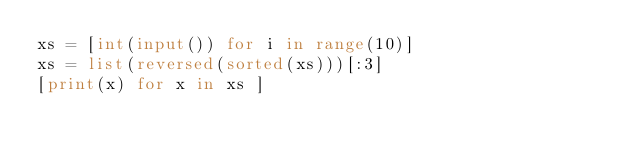<code> <loc_0><loc_0><loc_500><loc_500><_Python_>xs = [int(input()) for i in range(10)]
xs = list(reversed(sorted(xs)))[:3]
[print(x) for x in xs ] 
</code> 